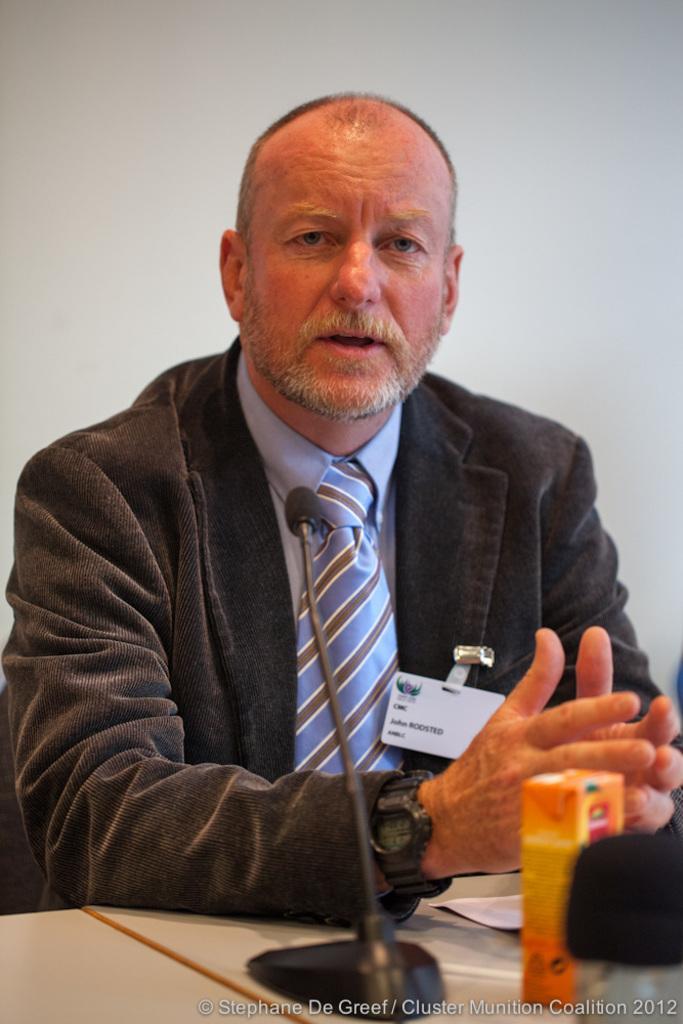Describe this image in one or two sentences. In the middle of the image a man is sitting and talking on the microphone. In front of him there is a table on the table there are two bottles and papers. Behind him there is a wall. 